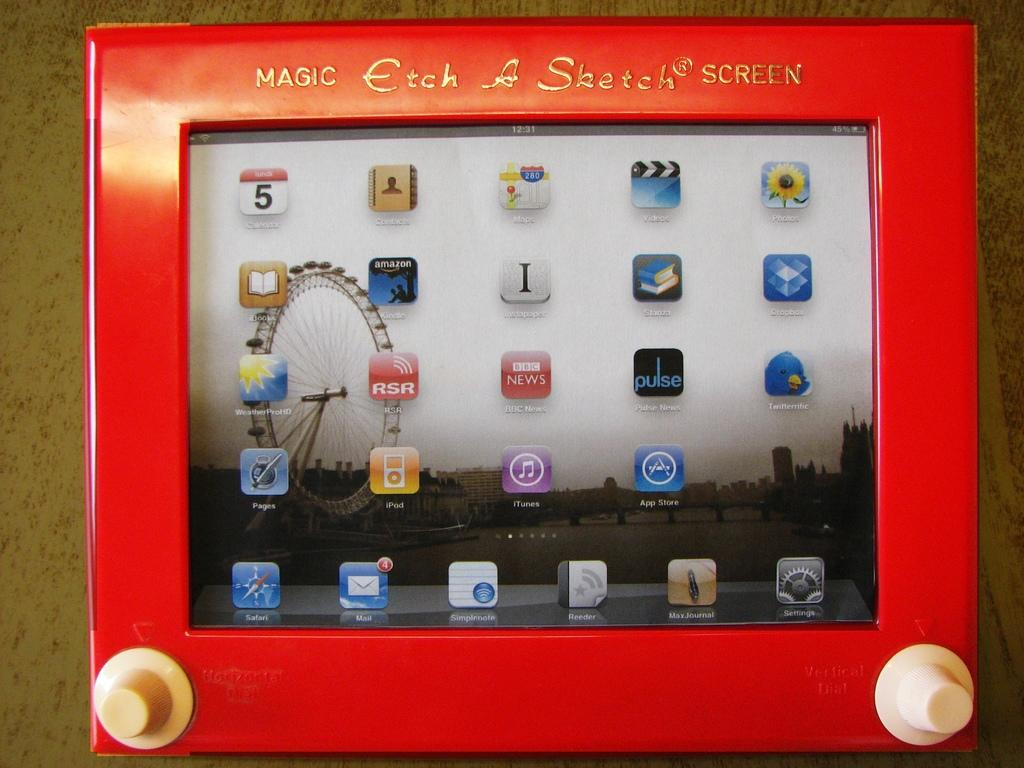What object is on the table in the image? There is a frame on the table. What is the purpose of the frame? The frame contains a screen. What can be seen on the screen? The screen displays app icons. Can you describe any specific feature on the screen? There is a joint wheel visible on the screen. What type of pan is being used to cook on the screen? There is no pan or cooking activity depicted on the screen; it displays app icons and a joint wheel. 